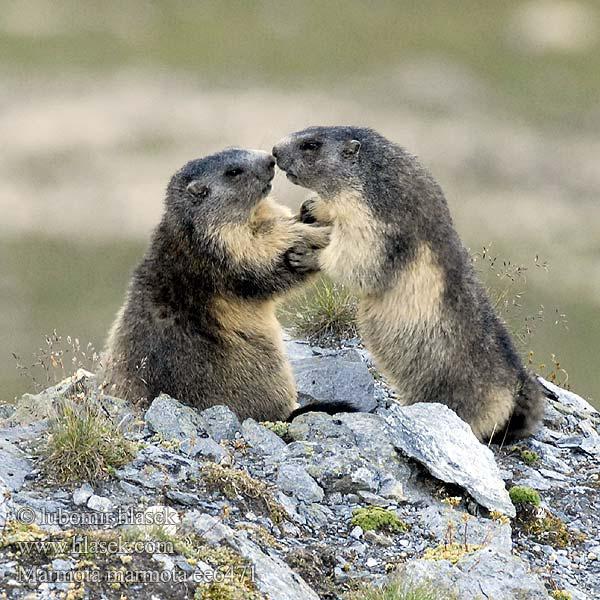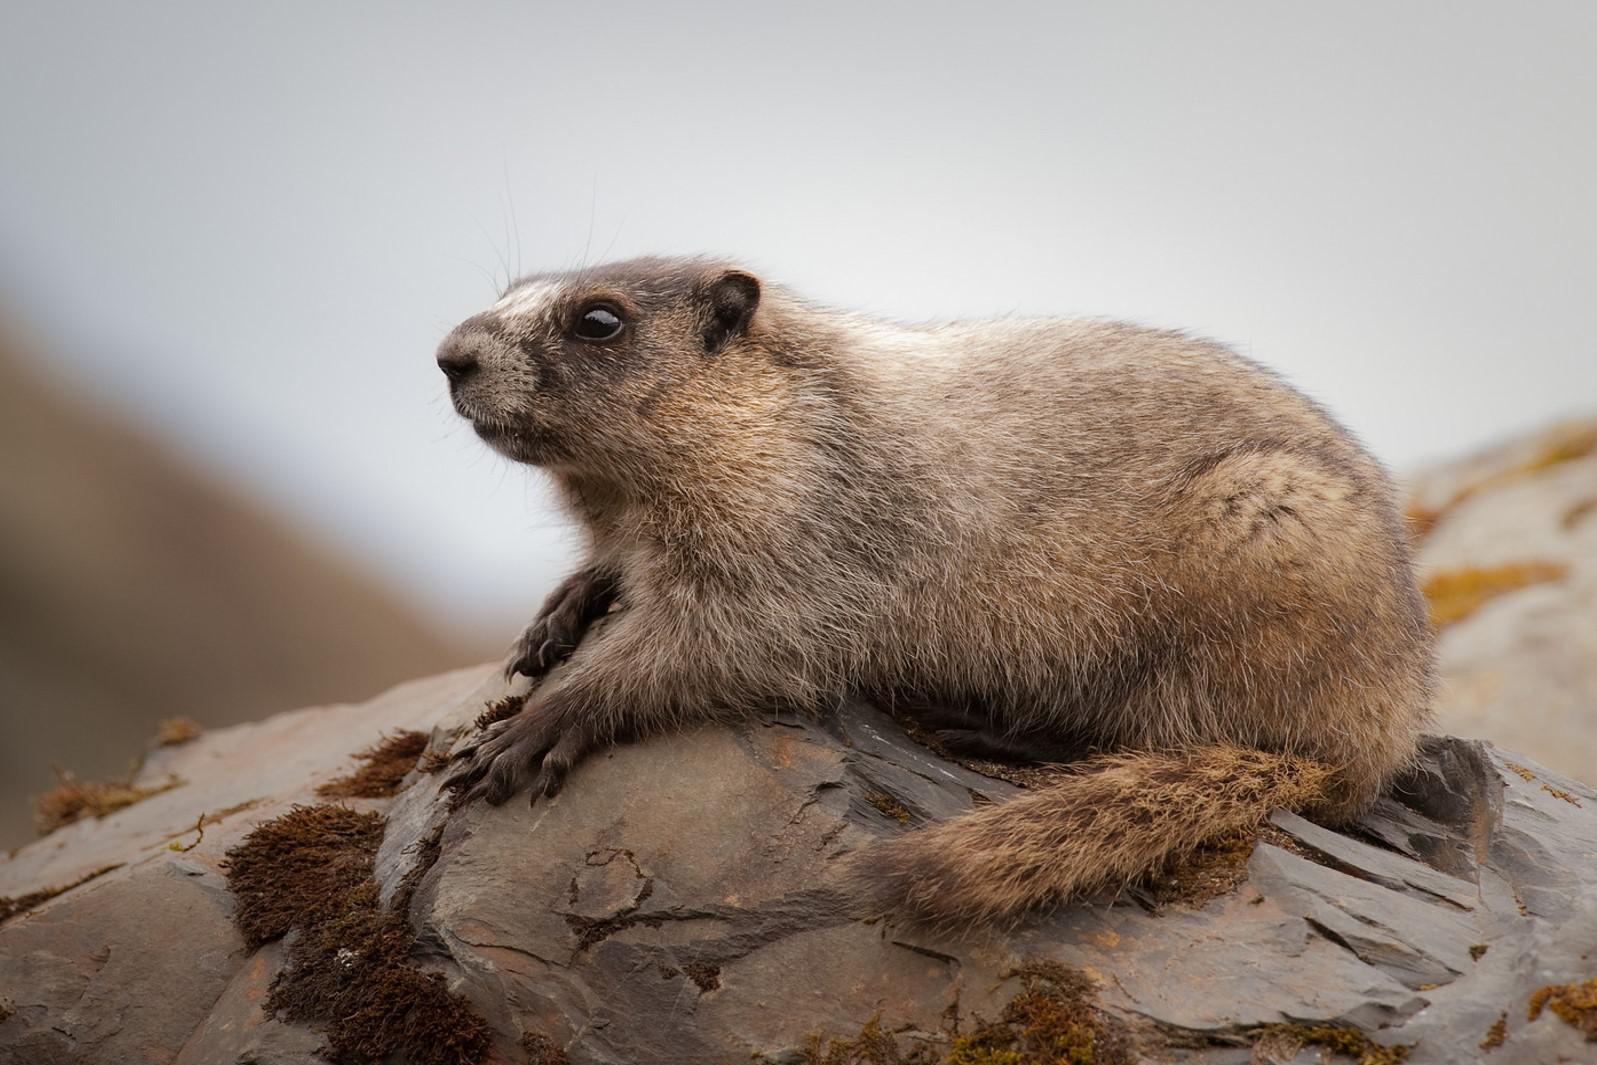The first image is the image on the left, the second image is the image on the right. For the images shown, is this caption "The right image contains one small animal facing leftward, with its body flat on a rock and its brown tail angled downward." true? Answer yes or no. Yes. The first image is the image on the left, the second image is the image on the right. Analyze the images presented: Is the assertion "the left and right image contains the same number of prairie dogs with long brown tales." valid? Answer yes or no. No. 